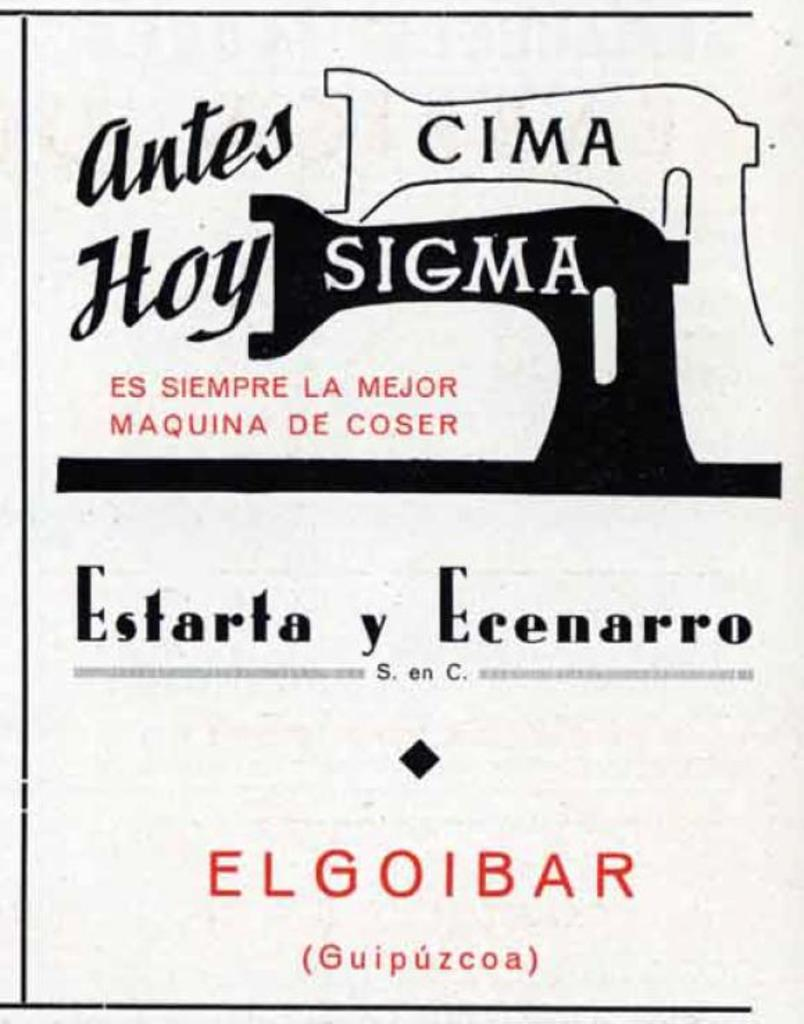<image>
Present a compact description of the photo's key features. A poster for Cima Sigma features black and red text. 